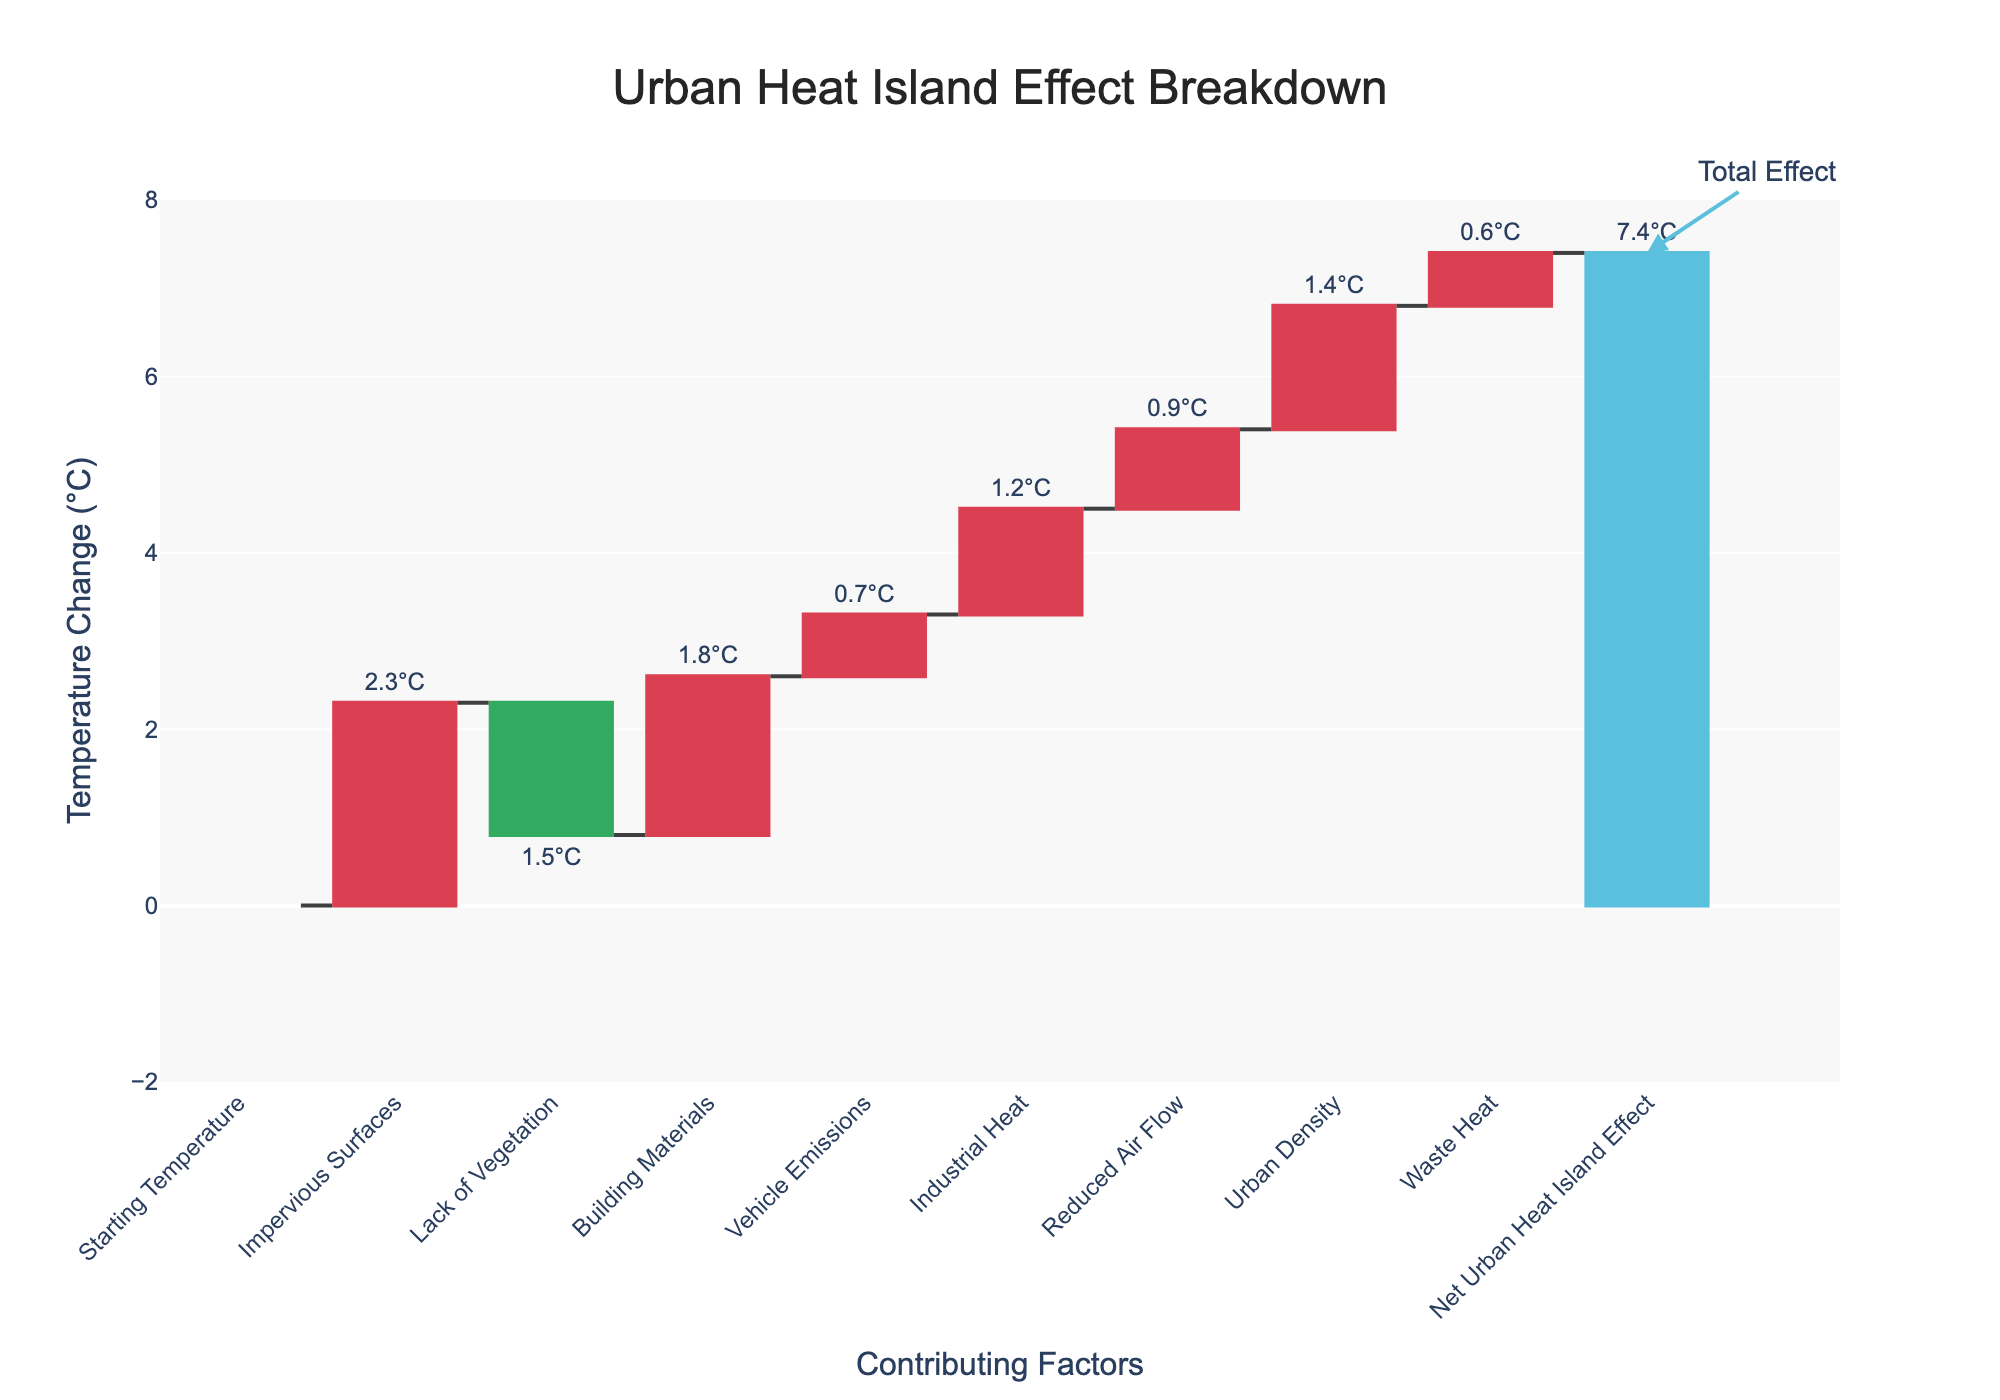What is the total Urban Heat Island effect? The total Urban Heat Island effect can be seen at the end of the waterfall chart under the category "Net Urban Heat Island Effect" which shows the cumulative effect of all contributing factors.
Answer: 7.4°C Which contributing factor has the highest positive impact on the Urban Heat Island effect? The categories with positive contributions can be identified by the increasing markers. "Impervious Surfaces" has the highest positive value of 2.3°C.
Answer: Impervious Surfaces How does the lack of vegetation contribute to the Urban Heat Island effect? The category "Lack of Vegetation" shows a negative contribution in the waterfall chart, which means it reduces the overall Urban Heat Island effect. The value is -1.5°C.
Answer: -1.5°C Compare the contributions of "Building Materials" and "Reduced Air Flow". Which has a greater impact? The contributions can be compared by their values. "Building Materials" contribute 1.8°C while "Reduced Air Flow" contributes 0.9°C. So, "Building Materials" has a greater impact.
Answer: Building Materials What is the combined effect of "Industrial Heat" and "Vehicle Emissions"? Adding the contributions of "Industrial Heat" (1.2°C) and "Vehicle Emissions" (0.7°C) gives the combined effect: 1.2 + 0.7 = 1.9°C.
Answer: 1.9°C How many factors contribute positively to the Urban Heat Island effect? By counting the categories with positive values: "Impervious Surfaces", "Building Materials", "Vehicle Emissions", "Industrial Heat", "Reduced Air Flow", "Urban Density", "Waste Heat". There are 7 factors.
Answer: 7 What would be the total Urban Heat Island effect if "Vehicle Emissions" were eliminated? The Urban Heat Island effect is currently 7.4°C. Subtract the contribution of "Vehicle Emissions" which is 0.7°C. The new total is 7.4 - 0.7 = 6.7°C.
Answer: 6.7°C Which factor has the least positive impact on the Urban Heat Island effect? Among the factors with positive contributions, the lowest value is "Waste Heat" with 0.6°C.
Answer: Waste Heat 